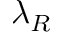Convert formula to latex. <formula><loc_0><loc_0><loc_500><loc_500>\lambda _ { R }</formula> 